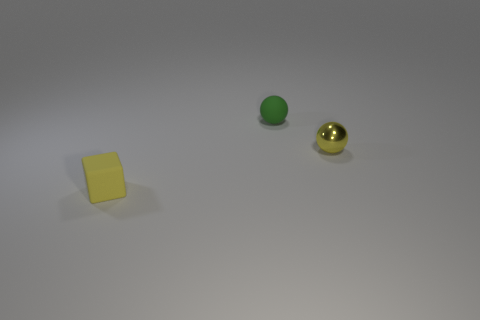Add 1 tiny matte spheres. How many objects exist? 4 Subtract all blocks. How many objects are left? 2 Add 2 tiny yellow shiny objects. How many tiny yellow shiny objects are left? 3 Add 3 tiny gray things. How many tiny gray things exist? 3 Subtract 0 cyan cubes. How many objects are left? 3 Subtract all matte things. Subtract all tiny green matte balls. How many objects are left? 0 